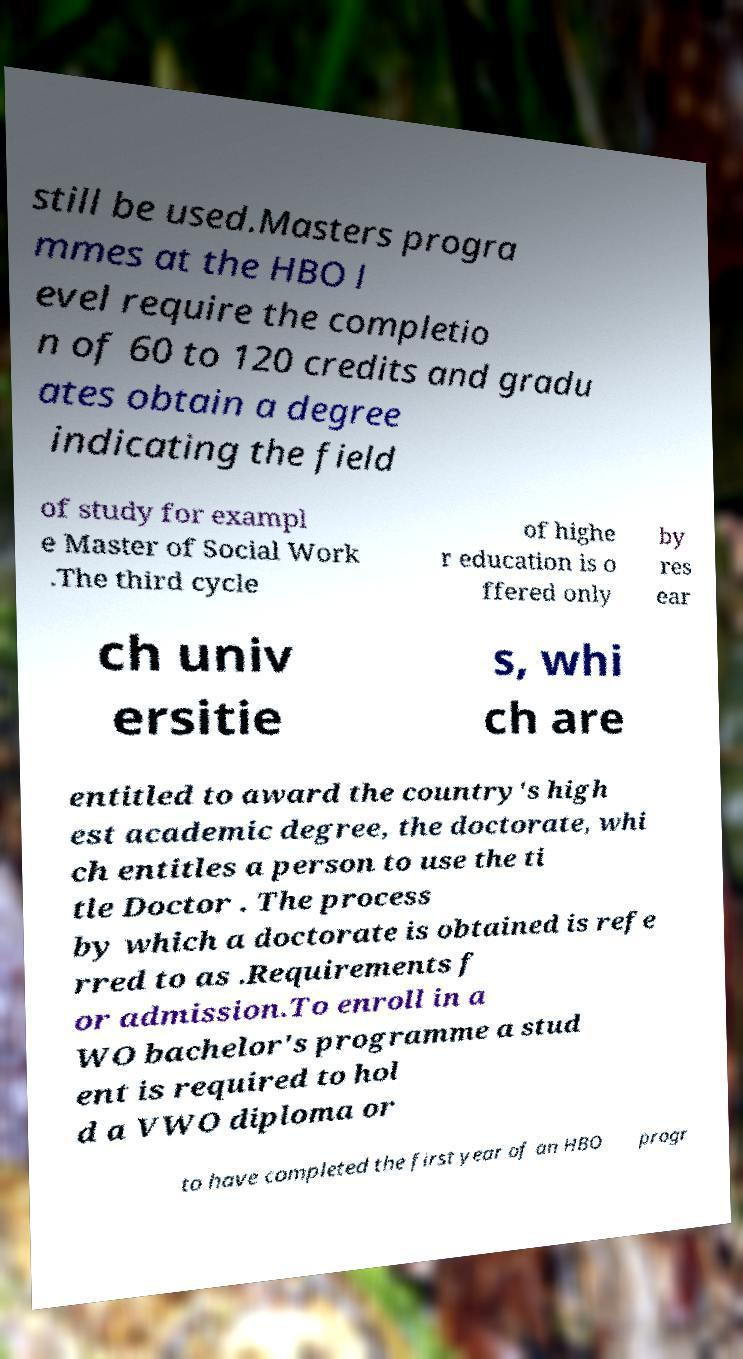Could you assist in decoding the text presented in this image and type it out clearly? still be used.Masters progra mmes at the HBO l evel require the completio n of 60 to 120 credits and gradu ates obtain a degree indicating the field of study for exampl e Master of Social Work .The third cycle of highe r education is o ffered only by res ear ch univ ersitie s, whi ch are entitled to award the country's high est academic degree, the doctorate, whi ch entitles a person to use the ti tle Doctor . The process by which a doctorate is obtained is refe rred to as .Requirements f or admission.To enroll in a WO bachelor's programme a stud ent is required to hol d a VWO diploma or to have completed the first year of an HBO progr 